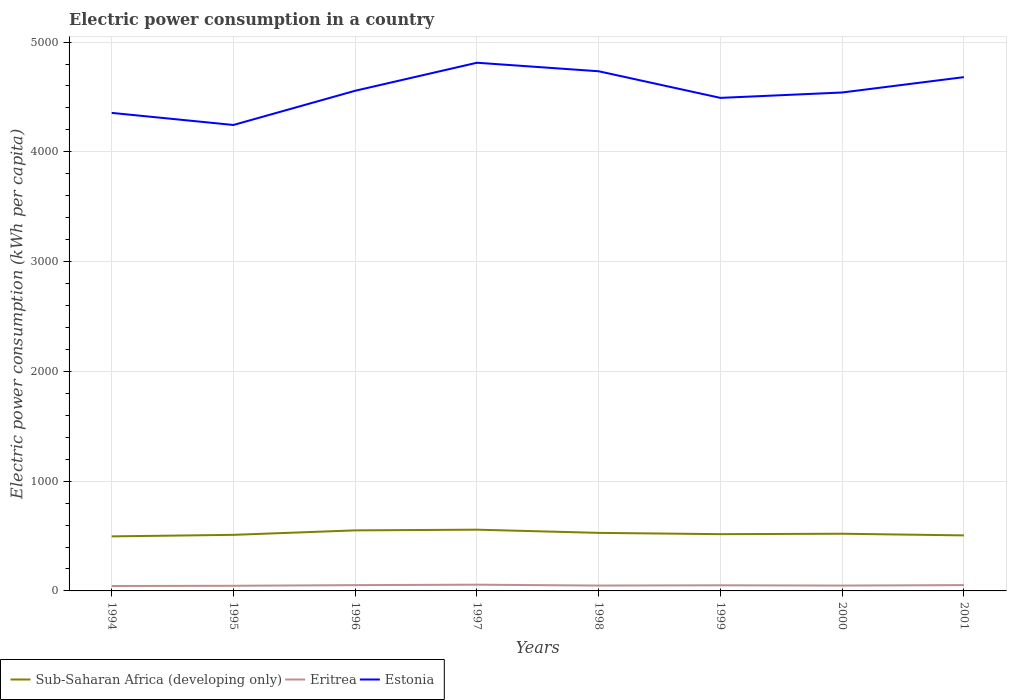How many different coloured lines are there?
Your answer should be compact. 3. Does the line corresponding to Eritrea intersect with the line corresponding to Sub-Saharan Africa (developing only)?
Offer a very short reply. No. Is the number of lines equal to the number of legend labels?
Offer a terse response. Yes. Across all years, what is the maximum electric power consumption in in Eritrea?
Keep it short and to the point. 44.79. In which year was the electric power consumption in in Sub-Saharan Africa (developing only) maximum?
Ensure brevity in your answer.  1994. What is the total electric power consumption in in Eritrea in the graph?
Provide a succinct answer. 3.66. What is the difference between the highest and the second highest electric power consumption in in Estonia?
Make the answer very short. 566.95. Is the electric power consumption in in Eritrea strictly greater than the electric power consumption in in Sub-Saharan Africa (developing only) over the years?
Ensure brevity in your answer.  Yes. Does the graph contain any zero values?
Provide a short and direct response. No. Does the graph contain grids?
Offer a terse response. Yes. How are the legend labels stacked?
Give a very brief answer. Horizontal. What is the title of the graph?
Offer a terse response. Electric power consumption in a country. Does "High income: nonOECD" appear as one of the legend labels in the graph?
Keep it short and to the point. No. What is the label or title of the X-axis?
Give a very brief answer. Years. What is the label or title of the Y-axis?
Your answer should be very brief. Electric power consumption (kWh per capita). What is the Electric power consumption (kWh per capita) in Sub-Saharan Africa (developing only) in 1994?
Your answer should be very brief. 496.9. What is the Electric power consumption (kWh per capita) in Eritrea in 1994?
Provide a short and direct response. 44.79. What is the Electric power consumption (kWh per capita) in Estonia in 1994?
Provide a short and direct response. 4354.83. What is the Electric power consumption (kWh per capita) in Sub-Saharan Africa (developing only) in 1995?
Your response must be concise. 510.9. What is the Electric power consumption (kWh per capita) of Eritrea in 1995?
Make the answer very short. 46.77. What is the Electric power consumption (kWh per capita) in Estonia in 1995?
Your answer should be very brief. 4244.64. What is the Electric power consumption (kWh per capita) of Sub-Saharan Africa (developing only) in 1996?
Make the answer very short. 551.54. What is the Electric power consumption (kWh per capita) of Eritrea in 1996?
Offer a very short reply. 52.77. What is the Electric power consumption (kWh per capita) in Estonia in 1996?
Ensure brevity in your answer.  4556.39. What is the Electric power consumption (kWh per capita) of Sub-Saharan Africa (developing only) in 1997?
Keep it short and to the point. 557.91. What is the Electric power consumption (kWh per capita) of Eritrea in 1997?
Provide a short and direct response. 56.74. What is the Electric power consumption (kWh per capita) of Estonia in 1997?
Offer a very short reply. 4811.6. What is the Electric power consumption (kWh per capita) in Sub-Saharan Africa (developing only) in 1998?
Your response must be concise. 528.77. What is the Electric power consumption (kWh per capita) in Eritrea in 1998?
Ensure brevity in your answer.  48.84. What is the Electric power consumption (kWh per capita) of Estonia in 1998?
Offer a very short reply. 4733.95. What is the Electric power consumption (kWh per capita) in Sub-Saharan Africa (developing only) in 1999?
Offer a terse response. 517.1. What is the Electric power consumption (kWh per capita) in Eritrea in 1999?
Give a very brief answer. 51.32. What is the Electric power consumption (kWh per capita) in Estonia in 1999?
Offer a very short reply. 4491.46. What is the Electric power consumption (kWh per capita) of Sub-Saharan Africa (developing only) in 2000?
Your response must be concise. 520.97. What is the Electric power consumption (kWh per capita) of Eritrea in 2000?
Your answer should be compact. 48.65. What is the Electric power consumption (kWh per capita) in Estonia in 2000?
Provide a succinct answer. 4540.49. What is the Electric power consumption (kWh per capita) in Sub-Saharan Africa (developing only) in 2001?
Make the answer very short. 505.86. What is the Electric power consumption (kWh per capita) in Eritrea in 2001?
Your answer should be compact. 53.08. What is the Electric power consumption (kWh per capita) in Estonia in 2001?
Ensure brevity in your answer.  4680.45. Across all years, what is the maximum Electric power consumption (kWh per capita) in Sub-Saharan Africa (developing only)?
Your answer should be very brief. 557.91. Across all years, what is the maximum Electric power consumption (kWh per capita) in Eritrea?
Give a very brief answer. 56.74. Across all years, what is the maximum Electric power consumption (kWh per capita) in Estonia?
Give a very brief answer. 4811.6. Across all years, what is the minimum Electric power consumption (kWh per capita) of Sub-Saharan Africa (developing only)?
Give a very brief answer. 496.9. Across all years, what is the minimum Electric power consumption (kWh per capita) of Eritrea?
Ensure brevity in your answer.  44.79. Across all years, what is the minimum Electric power consumption (kWh per capita) of Estonia?
Your response must be concise. 4244.64. What is the total Electric power consumption (kWh per capita) in Sub-Saharan Africa (developing only) in the graph?
Keep it short and to the point. 4189.94. What is the total Electric power consumption (kWh per capita) in Eritrea in the graph?
Make the answer very short. 402.97. What is the total Electric power consumption (kWh per capita) in Estonia in the graph?
Your response must be concise. 3.64e+04. What is the difference between the Electric power consumption (kWh per capita) of Sub-Saharan Africa (developing only) in 1994 and that in 1995?
Ensure brevity in your answer.  -14. What is the difference between the Electric power consumption (kWh per capita) in Eritrea in 1994 and that in 1995?
Your answer should be very brief. -1.98. What is the difference between the Electric power consumption (kWh per capita) of Estonia in 1994 and that in 1995?
Your response must be concise. 110.19. What is the difference between the Electric power consumption (kWh per capita) of Sub-Saharan Africa (developing only) in 1994 and that in 1996?
Provide a short and direct response. -54.65. What is the difference between the Electric power consumption (kWh per capita) of Eritrea in 1994 and that in 1996?
Your response must be concise. -7.98. What is the difference between the Electric power consumption (kWh per capita) in Estonia in 1994 and that in 1996?
Make the answer very short. -201.56. What is the difference between the Electric power consumption (kWh per capita) of Sub-Saharan Africa (developing only) in 1994 and that in 1997?
Provide a short and direct response. -61.02. What is the difference between the Electric power consumption (kWh per capita) of Eritrea in 1994 and that in 1997?
Make the answer very short. -11.95. What is the difference between the Electric power consumption (kWh per capita) in Estonia in 1994 and that in 1997?
Make the answer very short. -456.77. What is the difference between the Electric power consumption (kWh per capita) in Sub-Saharan Africa (developing only) in 1994 and that in 1998?
Your response must be concise. -31.87. What is the difference between the Electric power consumption (kWh per capita) of Eritrea in 1994 and that in 1998?
Provide a succinct answer. -4.05. What is the difference between the Electric power consumption (kWh per capita) of Estonia in 1994 and that in 1998?
Make the answer very short. -379.12. What is the difference between the Electric power consumption (kWh per capita) of Sub-Saharan Africa (developing only) in 1994 and that in 1999?
Make the answer very short. -20.2. What is the difference between the Electric power consumption (kWh per capita) in Eritrea in 1994 and that in 1999?
Give a very brief answer. -6.52. What is the difference between the Electric power consumption (kWh per capita) in Estonia in 1994 and that in 1999?
Offer a very short reply. -136.63. What is the difference between the Electric power consumption (kWh per capita) in Sub-Saharan Africa (developing only) in 1994 and that in 2000?
Provide a short and direct response. -24.07. What is the difference between the Electric power consumption (kWh per capita) in Eritrea in 1994 and that in 2000?
Offer a very short reply. -3.86. What is the difference between the Electric power consumption (kWh per capita) of Estonia in 1994 and that in 2000?
Offer a very short reply. -185.66. What is the difference between the Electric power consumption (kWh per capita) of Sub-Saharan Africa (developing only) in 1994 and that in 2001?
Your answer should be compact. -8.96. What is the difference between the Electric power consumption (kWh per capita) of Eritrea in 1994 and that in 2001?
Your answer should be very brief. -8.29. What is the difference between the Electric power consumption (kWh per capita) of Estonia in 1994 and that in 2001?
Your response must be concise. -325.62. What is the difference between the Electric power consumption (kWh per capita) in Sub-Saharan Africa (developing only) in 1995 and that in 1996?
Give a very brief answer. -40.64. What is the difference between the Electric power consumption (kWh per capita) in Eritrea in 1995 and that in 1996?
Ensure brevity in your answer.  -5.99. What is the difference between the Electric power consumption (kWh per capita) of Estonia in 1995 and that in 1996?
Make the answer very short. -311.75. What is the difference between the Electric power consumption (kWh per capita) of Sub-Saharan Africa (developing only) in 1995 and that in 1997?
Give a very brief answer. -47.01. What is the difference between the Electric power consumption (kWh per capita) of Eritrea in 1995 and that in 1997?
Your response must be concise. -9.96. What is the difference between the Electric power consumption (kWh per capita) of Estonia in 1995 and that in 1997?
Offer a very short reply. -566.95. What is the difference between the Electric power consumption (kWh per capita) in Sub-Saharan Africa (developing only) in 1995 and that in 1998?
Provide a succinct answer. -17.87. What is the difference between the Electric power consumption (kWh per capita) of Eritrea in 1995 and that in 1998?
Provide a succinct answer. -2.07. What is the difference between the Electric power consumption (kWh per capita) of Estonia in 1995 and that in 1998?
Provide a short and direct response. -489.31. What is the difference between the Electric power consumption (kWh per capita) of Sub-Saharan Africa (developing only) in 1995 and that in 1999?
Keep it short and to the point. -6.19. What is the difference between the Electric power consumption (kWh per capita) of Eritrea in 1995 and that in 1999?
Ensure brevity in your answer.  -4.54. What is the difference between the Electric power consumption (kWh per capita) in Estonia in 1995 and that in 1999?
Provide a short and direct response. -246.82. What is the difference between the Electric power consumption (kWh per capita) in Sub-Saharan Africa (developing only) in 1995 and that in 2000?
Keep it short and to the point. -10.07. What is the difference between the Electric power consumption (kWh per capita) of Eritrea in 1995 and that in 2000?
Keep it short and to the point. -1.88. What is the difference between the Electric power consumption (kWh per capita) in Estonia in 1995 and that in 2000?
Ensure brevity in your answer.  -295.85. What is the difference between the Electric power consumption (kWh per capita) in Sub-Saharan Africa (developing only) in 1995 and that in 2001?
Provide a succinct answer. 5.04. What is the difference between the Electric power consumption (kWh per capita) in Eritrea in 1995 and that in 2001?
Give a very brief answer. -6.3. What is the difference between the Electric power consumption (kWh per capita) in Estonia in 1995 and that in 2001?
Your answer should be compact. -435.8. What is the difference between the Electric power consumption (kWh per capita) of Sub-Saharan Africa (developing only) in 1996 and that in 1997?
Provide a short and direct response. -6.37. What is the difference between the Electric power consumption (kWh per capita) of Eritrea in 1996 and that in 1997?
Give a very brief answer. -3.97. What is the difference between the Electric power consumption (kWh per capita) of Estonia in 1996 and that in 1997?
Your response must be concise. -255.21. What is the difference between the Electric power consumption (kWh per capita) in Sub-Saharan Africa (developing only) in 1996 and that in 1998?
Provide a short and direct response. 22.77. What is the difference between the Electric power consumption (kWh per capita) of Eritrea in 1996 and that in 1998?
Ensure brevity in your answer.  3.93. What is the difference between the Electric power consumption (kWh per capita) in Estonia in 1996 and that in 1998?
Keep it short and to the point. -177.56. What is the difference between the Electric power consumption (kWh per capita) in Sub-Saharan Africa (developing only) in 1996 and that in 1999?
Ensure brevity in your answer.  34.45. What is the difference between the Electric power consumption (kWh per capita) of Eritrea in 1996 and that in 1999?
Keep it short and to the point. 1.45. What is the difference between the Electric power consumption (kWh per capita) of Estonia in 1996 and that in 1999?
Ensure brevity in your answer.  64.93. What is the difference between the Electric power consumption (kWh per capita) in Sub-Saharan Africa (developing only) in 1996 and that in 2000?
Offer a terse response. 30.57. What is the difference between the Electric power consumption (kWh per capita) in Eritrea in 1996 and that in 2000?
Your answer should be compact. 4.12. What is the difference between the Electric power consumption (kWh per capita) in Estonia in 1996 and that in 2000?
Give a very brief answer. 15.9. What is the difference between the Electric power consumption (kWh per capita) of Sub-Saharan Africa (developing only) in 1996 and that in 2001?
Offer a terse response. 45.69. What is the difference between the Electric power consumption (kWh per capita) of Eritrea in 1996 and that in 2001?
Provide a short and direct response. -0.31. What is the difference between the Electric power consumption (kWh per capita) in Estonia in 1996 and that in 2001?
Give a very brief answer. -124.06. What is the difference between the Electric power consumption (kWh per capita) in Sub-Saharan Africa (developing only) in 1997 and that in 1998?
Make the answer very short. 29.15. What is the difference between the Electric power consumption (kWh per capita) of Eritrea in 1997 and that in 1998?
Provide a succinct answer. 7.89. What is the difference between the Electric power consumption (kWh per capita) in Estonia in 1997 and that in 1998?
Offer a terse response. 77.64. What is the difference between the Electric power consumption (kWh per capita) in Sub-Saharan Africa (developing only) in 1997 and that in 1999?
Keep it short and to the point. 40.82. What is the difference between the Electric power consumption (kWh per capita) of Eritrea in 1997 and that in 1999?
Give a very brief answer. 5.42. What is the difference between the Electric power consumption (kWh per capita) in Estonia in 1997 and that in 1999?
Keep it short and to the point. 320.14. What is the difference between the Electric power consumption (kWh per capita) in Sub-Saharan Africa (developing only) in 1997 and that in 2000?
Keep it short and to the point. 36.94. What is the difference between the Electric power consumption (kWh per capita) of Eritrea in 1997 and that in 2000?
Ensure brevity in your answer.  8.08. What is the difference between the Electric power consumption (kWh per capita) of Estonia in 1997 and that in 2000?
Provide a short and direct response. 271.11. What is the difference between the Electric power consumption (kWh per capita) in Sub-Saharan Africa (developing only) in 1997 and that in 2001?
Make the answer very short. 52.06. What is the difference between the Electric power consumption (kWh per capita) of Eritrea in 1997 and that in 2001?
Offer a terse response. 3.66. What is the difference between the Electric power consumption (kWh per capita) of Estonia in 1997 and that in 2001?
Provide a succinct answer. 131.15. What is the difference between the Electric power consumption (kWh per capita) of Sub-Saharan Africa (developing only) in 1998 and that in 1999?
Your response must be concise. 11.67. What is the difference between the Electric power consumption (kWh per capita) in Eritrea in 1998 and that in 1999?
Provide a short and direct response. -2.47. What is the difference between the Electric power consumption (kWh per capita) in Estonia in 1998 and that in 1999?
Give a very brief answer. 242.49. What is the difference between the Electric power consumption (kWh per capita) in Sub-Saharan Africa (developing only) in 1998 and that in 2000?
Provide a succinct answer. 7.8. What is the difference between the Electric power consumption (kWh per capita) of Eritrea in 1998 and that in 2000?
Provide a succinct answer. 0.19. What is the difference between the Electric power consumption (kWh per capita) in Estonia in 1998 and that in 2000?
Give a very brief answer. 193.46. What is the difference between the Electric power consumption (kWh per capita) in Sub-Saharan Africa (developing only) in 1998 and that in 2001?
Give a very brief answer. 22.91. What is the difference between the Electric power consumption (kWh per capita) of Eritrea in 1998 and that in 2001?
Give a very brief answer. -4.23. What is the difference between the Electric power consumption (kWh per capita) in Estonia in 1998 and that in 2001?
Keep it short and to the point. 53.51. What is the difference between the Electric power consumption (kWh per capita) of Sub-Saharan Africa (developing only) in 1999 and that in 2000?
Give a very brief answer. -3.87. What is the difference between the Electric power consumption (kWh per capita) in Eritrea in 1999 and that in 2000?
Your answer should be compact. 2.66. What is the difference between the Electric power consumption (kWh per capita) in Estonia in 1999 and that in 2000?
Ensure brevity in your answer.  -49.03. What is the difference between the Electric power consumption (kWh per capita) in Sub-Saharan Africa (developing only) in 1999 and that in 2001?
Your answer should be very brief. 11.24. What is the difference between the Electric power consumption (kWh per capita) in Eritrea in 1999 and that in 2001?
Provide a short and direct response. -1.76. What is the difference between the Electric power consumption (kWh per capita) in Estonia in 1999 and that in 2001?
Your answer should be compact. -188.99. What is the difference between the Electric power consumption (kWh per capita) in Sub-Saharan Africa (developing only) in 2000 and that in 2001?
Offer a very short reply. 15.11. What is the difference between the Electric power consumption (kWh per capita) in Eritrea in 2000 and that in 2001?
Offer a terse response. -4.42. What is the difference between the Electric power consumption (kWh per capita) in Estonia in 2000 and that in 2001?
Give a very brief answer. -139.96. What is the difference between the Electric power consumption (kWh per capita) in Sub-Saharan Africa (developing only) in 1994 and the Electric power consumption (kWh per capita) in Eritrea in 1995?
Provide a succinct answer. 450.12. What is the difference between the Electric power consumption (kWh per capita) of Sub-Saharan Africa (developing only) in 1994 and the Electric power consumption (kWh per capita) of Estonia in 1995?
Keep it short and to the point. -3747.75. What is the difference between the Electric power consumption (kWh per capita) of Eritrea in 1994 and the Electric power consumption (kWh per capita) of Estonia in 1995?
Your answer should be compact. -4199.85. What is the difference between the Electric power consumption (kWh per capita) of Sub-Saharan Africa (developing only) in 1994 and the Electric power consumption (kWh per capita) of Eritrea in 1996?
Your answer should be compact. 444.13. What is the difference between the Electric power consumption (kWh per capita) in Sub-Saharan Africa (developing only) in 1994 and the Electric power consumption (kWh per capita) in Estonia in 1996?
Provide a short and direct response. -4059.49. What is the difference between the Electric power consumption (kWh per capita) of Eritrea in 1994 and the Electric power consumption (kWh per capita) of Estonia in 1996?
Your answer should be very brief. -4511.6. What is the difference between the Electric power consumption (kWh per capita) in Sub-Saharan Africa (developing only) in 1994 and the Electric power consumption (kWh per capita) in Eritrea in 1997?
Keep it short and to the point. 440.16. What is the difference between the Electric power consumption (kWh per capita) in Sub-Saharan Africa (developing only) in 1994 and the Electric power consumption (kWh per capita) in Estonia in 1997?
Offer a terse response. -4314.7. What is the difference between the Electric power consumption (kWh per capita) in Eritrea in 1994 and the Electric power consumption (kWh per capita) in Estonia in 1997?
Provide a short and direct response. -4766.81. What is the difference between the Electric power consumption (kWh per capita) of Sub-Saharan Africa (developing only) in 1994 and the Electric power consumption (kWh per capita) of Eritrea in 1998?
Provide a short and direct response. 448.05. What is the difference between the Electric power consumption (kWh per capita) of Sub-Saharan Africa (developing only) in 1994 and the Electric power consumption (kWh per capita) of Estonia in 1998?
Your answer should be very brief. -4237.06. What is the difference between the Electric power consumption (kWh per capita) of Eritrea in 1994 and the Electric power consumption (kWh per capita) of Estonia in 1998?
Keep it short and to the point. -4689.16. What is the difference between the Electric power consumption (kWh per capita) in Sub-Saharan Africa (developing only) in 1994 and the Electric power consumption (kWh per capita) in Eritrea in 1999?
Provide a short and direct response. 445.58. What is the difference between the Electric power consumption (kWh per capita) of Sub-Saharan Africa (developing only) in 1994 and the Electric power consumption (kWh per capita) of Estonia in 1999?
Give a very brief answer. -3994.56. What is the difference between the Electric power consumption (kWh per capita) of Eritrea in 1994 and the Electric power consumption (kWh per capita) of Estonia in 1999?
Offer a terse response. -4446.67. What is the difference between the Electric power consumption (kWh per capita) of Sub-Saharan Africa (developing only) in 1994 and the Electric power consumption (kWh per capita) of Eritrea in 2000?
Keep it short and to the point. 448.24. What is the difference between the Electric power consumption (kWh per capita) of Sub-Saharan Africa (developing only) in 1994 and the Electric power consumption (kWh per capita) of Estonia in 2000?
Ensure brevity in your answer.  -4043.6. What is the difference between the Electric power consumption (kWh per capita) of Eritrea in 1994 and the Electric power consumption (kWh per capita) of Estonia in 2000?
Make the answer very short. -4495.7. What is the difference between the Electric power consumption (kWh per capita) of Sub-Saharan Africa (developing only) in 1994 and the Electric power consumption (kWh per capita) of Eritrea in 2001?
Provide a short and direct response. 443.82. What is the difference between the Electric power consumption (kWh per capita) of Sub-Saharan Africa (developing only) in 1994 and the Electric power consumption (kWh per capita) of Estonia in 2001?
Offer a terse response. -4183.55. What is the difference between the Electric power consumption (kWh per capita) of Eritrea in 1994 and the Electric power consumption (kWh per capita) of Estonia in 2001?
Make the answer very short. -4635.66. What is the difference between the Electric power consumption (kWh per capita) in Sub-Saharan Africa (developing only) in 1995 and the Electric power consumption (kWh per capita) in Eritrea in 1996?
Offer a very short reply. 458.13. What is the difference between the Electric power consumption (kWh per capita) in Sub-Saharan Africa (developing only) in 1995 and the Electric power consumption (kWh per capita) in Estonia in 1996?
Offer a terse response. -4045.49. What is the difference between the Electric power consumption (kWh per capita) in Eritrea in 1995 and the Electric power consumption (kWh per capita) in Estonia in 1996?
Provide a succinct answer. -4509.62. What is the difference between the Electric power consumption (kWh per capita) of Sub-Saharan Africa (developing only) in 1995 and the Electric power consumption (kWh per capita) of Eritrea in 1997?
Give a very brief answer. 454.16. What is the difference between the Electric power consumption (kWh per capita) in Sub-Saharan Africa (developing only) in 1995 and the Electric power consumption (kWh per capita) in Estonia in 1997?
Offer a very short reply. -4300.7. What is the difference between the Electric power consumption (kWh per capita) in Eritrea in 1995 and the Electric power consumption (kWh per capita) in Estonia in 1997?
Give a very brief answer. -4764.82. What is the difference between the Electric power consumption (kWh per capita) in Sub-Saharan Africa (developing only) in 1995 and the Electric power consumption (kWh per capita) in Eritrea in 1998?
Your response must be concise. 462.06. What is the difference between the Electric power consumption (kWh per capita) of Sub-Saharan Africa (developing only) in 1995 and the Electric power consumption (kWh per capita) of Estonia in 1998?
Your response must be concise. -4223.05. What is the difference between the Electric power consumption (kWh per capita) of Eritrea in 1995 and the Electric power consumption (kWh per capita) of Estonia in 1998?
Offer a terse response. -4687.18. What is the difference between the Electric power consumption (kWh per capita) of Sub-Saharan Africa (developing only) in 1995 and the Electric power consumption (kWh per capita) of Eritrea in 1999?
Provide a short and direct response. 459.58. What is the difference between the Electric power consumption (kWh per capita) in Sub-Saharan Africa (developing only) in 1995 and the Electric power consumption (kWh per capita) in Estonia in 1999?
Keep it short and to the point. -3980.56. What is the difference between the Electric power consumption (kWh per capita) in Eritrea in 1995 and the Electric power consumption (kWh per capita) in Estonia in 1999?
Your answer should be compact. -4444.69. What is the difference between the Electric power consumption (kWh per capita) of Sub-Saharan Africa (developing only) in 1995 and the Electric power consumption (kWh per capita) of Eritrea in 2000?
Offer a terse response. 462.25. What is the difference between the Electric power consumption (kWh per capita) of Sub-Saharan Africa (developing only) in 1995 and the Electric power consumption (kWh per capita) of Estonia in 2000?
Keep it short and to the point. -4029.59. What is the difference between the Electric power consumption (kWh per capita) of Eritrea in 1995 and the Electric power consumption (kWh per capita) of Estonia in 2000?
Your answer should be compact. -4493.72. What is the difference between the Electric power consumption (kWh per capita) of Sub-Saharan Africa (developing only) in 1995 and the Electric power consumption (kWh per capita) of Eritrea in 2001?
Your answer should be compact. 457.82. What is the difference between the Electric power consumption (kWh per capita) in Sub-Saharan Africa (developing only) in 1995 and the Electric power consumption (kWh per capita) in Estonia in 2001?
Offer a terse response. -4169.55. What is the difference between the Electric power consumption (kWh per capita) in Eritrea in 1995 and the Electric power consumption (kWh per capita) in Estonia in 2001?
Give a very brief answer. -4633.67. What is the difference between the Electric power consumption (kWh per capita) of Sub-Saharan Africa (developing only) in 1996 and the Electric power consumption (kWh per capita) of Eritrea in 1997?
Offer a terse response. 494.8. What is the difference between the Electric power consumption (kWh per capita) in Sub-Saharan Africa (developing only) in 1996 and the Electric power consumption (kWh per capita) in Estonia in 1997?
Ensure brevity in your answer.  -4260.06. What is the difference between the Electric power consumption (kWh per capita) in Eritrea in 1996 and the Electric power consumption (kWh per capita) in Estonia in 1997?
Offer a very short reply. -4758.83. What is the difference between the Electric power consumption (kWh per capita) in Sub-Saharan Africa (developing only) in 1996 and the Electric power consumption (kWh per capita) in Eritrea in 1998?
Offer a terse response. 502.7. What is the difference between the Electric power consumption (kWh per capita) of Sub-Saharan Africa (developing only) in 1996 and the Electric power consumption (kWh per capita) of Estonia in 1998?
Keep it short and to the point. -4182.41. What is the difference between the Electric power consumption (kWh per capita) in Eritrea in 1996 and the Electric power consumption (kWh per capita) in Estonia in 1998?
Ensure brevity in your answer.  -4681.19. What is the difference between the Electric power consumption (kWh per capita) in Sub-Saharan Africa (developing only) in 1996 and the Electric power consumption (kWh per capita) in Eritrea in 1999?
Your answer should be compact. 500.22. What is the difference between the Electric power consumption (kWh per capita) of Sub-Saharan Africa (developing only) in 1996 and the Electric power consumption (kWh per capita) of Estonia in 1999?
Make the answer very short. -3939.92. What is the difference between the Electric power consumption (kWh per capita) of Eritrea in 1996 and the Electric power consumption (kWh per capita) of Estonia in 1999?
Provide a short and direct response. -4438.69. What is the difference between the Electric power consumption (kWh per capita) in Sub-Saharan Africa (developing only) in 1996 and the Electric power consumption (kWh per capita) in Eritrea in 2000?
Offer a very short reply. 502.89. What is the difference between the Electric power consumption (kWh per capita) of Sub-Saharan Africa (developing only) in 1996 and the Electric power consumption (kWh per capita) of Estonia in 2000?
Give a very brief answer. -3988.95. What is the difference between the Electric power consumption (kWh per capita) of Eritrea in 1996 and the Electric power consumption (kWh per capita) of Estonia in 2000?
Make the answer very short. -4487.72. What is the difference between the Electric power consumption (kWh per capita) of Sub-Saharan Africa (developing only) in 1996 and the Electric power consumption (kWh per capita) of Eritrea in 2001?
Keep it short and to the point. 498.46. What is the difference between the Electric power consumption (kWh per capita) of Sub-Saharan Africa (developing only) in 1996 and the Electric power consumption (kWh per capita) of Estonia in 2001?
Provide a short and direct response. -4128.91. What is the difference between the Electric power consumption (kWh per capita) of Eritrea in 1996 and the Electric power consumption (kWh per capita) of Estonia in 2001?
Your answer should be compact. -4627.68. What is the difference between the Electric power consumption (kWh per capita) of Sub-Saharan Africa (developing only) in 1997 and the Electric power consumption (kWh per capita) of Eritrea in 1998?
Ensure brevity in your answer.  509.07. What is the difference between the Electric power consumption (kWh per capita) of Sub-Saharan Africa (developing only) in 1997 and the Electric power consumption (kWh per capita) of Estonia in 1998?
Your answer should be compact. -4176.04. What is the difference between the Electric power consumption (kWh per capita) in Eritrea in 1997 and the Electric power consumption (kWh per capita) in Estonia in 1998?
Your answer should be compact. -4677.22. What is the difference between the Electric power consumption (kWh per capita) in Sub-Saharan Africa (developing only) in 1997 and the Electric power consumption (kWh per capita) in Eritrea in 1999?
Provide a succinct answer. 506.6. What is the difference between the Electric power consumption (kWh per capita) of Sub-Saharan Africa (developing only) in 1997 and the Electric power consumption (kWh per capita) of Estonia in 1999?
Your answer should be very brief. -3933.55. What is the difference between the Electric power consumption (kWh per capita) of Eritrea in 1997 and the Electric power consumption (kWh per capita) of Estonia in 1999?
Keep it short and to the point. -4434.72. What is the difference between the Electric power consumption (kWh per capita) in Sub-Saharan Africa (developing only) in 1997 and the Electric power consumption (kWh per capita) in Eritrea in 2000?
Provide a short and direct response. 509.26. What is the difference between the Electric power consumption (kWh per capita) of Sub-Saharan Africa (developing only) in 1997 and the Electric power consumption (kWh per capita) of Estonia in 2000?
Provide a short and direct response. -3982.58. What is the difference between the Electric power consumption (kWh per capita) of Eritrea in 1997 and the Electric power consumption (kWh per capita) of Estonia in 2000?
Your response must be concise. -4483.75. What is the difference between the Electric power consumption (kWh per capita) of Sub-Saharan Africa (developing only) in 1997 and the Electric power consumption (kWh per capita) of Eritrea in 2001?
Make the answer very short. 504.84. What is the difference between the Electric power consumption (kWh per capita) of Sub-Saharan Africa (developing only) in 1997 and the Electric power consumption (kWh per capita) of Estonia in 2001?
Your response must be concise. -4122.53. What is the difference between the Electric power consumption (kWh per capita) in Eritrea in 1997 and the Electric power consumption (kWh per capita) in Estonia in 2001?
Provide a succinct answer. -4623.71. What is the difference between the Electric power consumption (kWh per capita) of Sub-Saharan Africa (developing only) in 1998 and the Electric power consumption (kWh per capita) of Eritrea in 1999?
Keep it short and to the point. 477.45. What is the difference between the Electric power consumption (kWh per capita) of Sub-Saharan Africa (developing only) in 1998 and the Electric power consumption (kWh per capita) of Estonia in 1999?
Ensure brevity in your answer.  -3962.69. What is the difference between the Electric power consumption (kWh per capita) of Eritrea in 1998 and the Electric power consumption (kWh per capita) of Estonia in 1999?
Ensure brevity in your answer.  -4442.62. What is the difference between the Electric power consumption (kWh per capita) in Sub-Saharan Africa (developing only) in 1998 and the Electric power consumption (kWh per capita) in Eritrea in 2000?
Give a very brief answer. 480.11. What is the difference between the Electric power consumption (kWh per capita) in Sub-Saharan Africa (developing only) in 1998 and the Electric power consumption (kWh per capita) in Estonia in 2000?
Provide a succinct answer. -4011.72. What is the difference between the Electric power consumption (kWh per capita) in Eritrea in 1998 and the Electric power consumption (kWh per capita) in Estonia in 2000?
Give a very brief answer. -4491.65. What is the difference between the Electric power consumption (kWh per capita) of Sub-Saharan Africa (developing only) in 1998 and the Electric power consumption (kWh per capita) of Eritrea in 2001?
Your answer should be very brief. 475.69. What is the difference between the Electric power consumption (kWh per capita) in Sub-Saharan Africa (developing only) in 1998 and the Electric power consumption (kWh per capita) in Estonia in 2001?
Offer a terse response. -4151.68. What is the difference between the Electric power consumption (kWh per capita) in Eritrea in 1998 and the Electric power consumption (kWh per capita) in Estonia in 2001?
Your answer should be compact. -4631.6. What is the difference between the Electric power consumption (kWh per capita) in Sub-Saharan Africa (developing only) in 1999 and the Electric power consumption (kWh per capita) in Eritrea in 2000?
Provide a short and direct response. 468.44. What is the difference between the Electric power consumption (kWh per capita) of Sub-Saharan Africa (developing only) in 1999 and the Electric power consumption (kWh per capita) of Estonia in 2000?
Give a very brief answer. -4023.4. What is the difference between the Electric power consumption (kWh per capita) in Eritrea in 1999 and the Electric power consumption (kWh per capita) in Estonia in 2000?
Give a very brief answer. -4489.18. What is the difference between the Electric power consumption (kWh per capita) of Sub-Saharan Africa (developing only) in 1999 and the Electric power consumption (kWh per capita) of Eritrea in 2001?
Your answer should be compact. 464.02. What is the difference between the Electric power consumption (kWh per capita) of Sub-Saharan Africa (developing only) in 1999 and the Electric power consumption (kWh per capita) of Estonia in 2001?
Your answer should be very brief. -4163.35. What is the difference between the Electric power consumption (kWh per capita) in Eritrea in 1999 and the Electric power consumption (kWh per capita) in Estonia in 2001?
Your response must be concise. -4629.13. What is the difference between the Electric power consumption (kWh per capita) in Sub-Saharan Africa (developing only) in 2000 and the Electric power consumption (kWh per capita) in Eritrea in 2001?
Provide a short and direct response. 467.89. What is the difference between the Electric power consumption (kWh per capita) in Sub-Saharan Africa (developing only) in 2000 and the Electric power consumption (kWh per capita) in Estonia in 2001?
Provide a succinct answer. -4159.48. What is the difference between the Electric power consumption (kWh per capita) of Eritrea in 2000 and the Electric power consumption (kWh per capita) of Estonia in 2001?
Offer a terse response. -4631.79. What is the average Electric power consumption (kWh per capita) in Sub-Saharan Africa (developing only) per year?
Make the answer very short. 523.74. What is the average Electric power consumption (kWh per capita) in Eritrea per year?
Your answer should be compact. 50.37. What is the average Electric power consumption (kWh per capita) in Estonia per year?
Keep it short and to the point. 4551.73. In the year 1994, what is the difference between the Electric power consumption (kWh per capita) of Sub-Saharan Africa (developing only) and Electric power consumption (kWh per capita) of Eritrea?
Make the answer very short. 452.1. In the year 1994, what is the difference between the Electric power consumption (kWh per capita) in Sub-Saharan Africa (developing only) and Electric power consumption (kWh per capita) in Estonia?
Your response must be concise. -3857.93. In the year 1994, what is the difference between the Electric power consumption (kWh per capita) of Eritrea and Electric power consumption (kWh per capita) of Estonia?
Provide a short and direct response. -4310.04. In the year 1995, what is the difference between the Electric power consumption (kWh per capita) in Sub-Saharan Africa (developing only) and Electric power consumption (kWh per capita) in Eritrea?
Ensure brevity in your answer.  464.13. In the year 1995, what is the difference between the Electric power consumption (kWh per capita) in Sub-Saharan Africa (developing only) and Electric power consumption (kWh per capita) in Estonia?
Keep it short and to the point. -3733.74. In the year 1995, what is the difference between the Electric power consumption (kWh per capita) in Eritrea and Electric power consumption (kWh per capita) in Estonia?
Ensure brevity in your answer.  -4197.87. In the year 1996, what is the difference between the Electric power consumption (kWh per capita) in Sub-Saharan Africa (developing only) and Electric power consumption (kWh per capita) in Eritrea?
Offer a terse response. 498.77. In the year 1996, what is the difference between the Electric power consumption (kWh per capita) in Sub-Saharan Africa (developing only) and Electric power consumption (kWh per capita) in Estonia?
Provide a short and direct response. -4004.85. In the year 1996, what is the difference between the Electric power consumption (kWh per capita) in Eritrea and Electric power consumption (kWh per capita) in Estonia?
Your answer should be very brief. -4503.62. In the year 1997, what is the difference between the Electric power consumption (kWh per capita) in Sub-Saharan Africa (developing only) and Electric power consumption (kWh per capita) in Eritrea?
Provide a short and direct response. 501.18. In the year 1997, what is the difference between the Electric power consumption (kWh per capita) of Sub-Saharan Africa (developing only) and Electric power consumption (kWh per capita) of Estonia?
Ensure brevity in your answer.  -4253.68. In the year 1997, what is the difference between the Electric power consumption (kWh per capita) in Eritrea and Electric power consumption (kWh per capita) in Estonia?
Make the answer very short. -4754.86. In the year 1998, what is the difference between the Electric power consumption (kWh per capita) of Sub-Saharan Africa (developing only) and Electric power consumption (kWh per capita) of Eritrea?
Offer a terse response. 479.93. In the year 1998, what is the difference between the Electric power consumption (kWh per capita) of Sub-Saharan Africa (developing only) and Electric power consumption (kWh per capita) of Estonia?
Your response must be concise. -4205.19. In the year 1998, what is the difference between the Electric power consumption (kWh per capita) of Eritrea and Electric power consumption (kWh per capita) of Estonia?
Give a very brief answer. -4685.11. In the year 1999, what is the difference between the Electric power consumption (kWh per capita) of Sub-Saharan Africa (developing only) and Electric power consumption (kWh per capita) of Eritrea?
Provide a succinct answer. 465.78. In the year 1999, what is the difference between the Electric power consumption (kWh per capita) in Sub-Saharan Africa (developing only) and Electric power consumption (kWh per capita) in Estonia?
Your response must be concise. -3974.36. In the year 1999, what is the difference between the Electric power consumption (kWh per capita) of Eritrea and Electric power consumption (kWh per capita) of Estonia?
Your answer should be very brief. -4440.14. In the year 2000, what is the difference between the Electric power consumption (kWh per capita) of Sub-Saharan Africa (developing only) and Electric power consumption (kWh per capita) of Eritrea?
Offer a very short reply. 472.32. In the year 2000, what is the difference between the Electric power consumption (kWh per capita) in Sub-Saharan Africa (developing only) and Electric power consumption (kWh per capita) in Estonia?
Ensure brevity in your answer.  -4019.52. In the year 2000, what is the difference between the Electric power consumption (kWh per capita) in Eritrea and Electric power consumption (kWh per capita) in Estonia?
Ensure brevity in your answer.  -4491.84. In the year 2001, what is the difference between the Electric power consumption (kWh per capita) of Sub-Saharan Africa (developing only) and Electric power consumption (kWh per capita) of Eritrea?
Your answer should be very brief. 452.78. In the year 2001, what is the difference between the Electric power consumption (kWh per capita) of Sub-Saharan Africa (developing only) and Electric power consumption (kWh per capita) of Estonia?
Offer a very short reply. -4174.59. In the year 2001, what is the difference between the Electric power consumption (kWh per capita) in Eritrea and Electric power consumption (kWh per capita) in Estonia?
Make the answer very short. -4627.37. What is the ratio of the Electric power consumption (kWh per capita) in Sub-Saharan Africa (developing only) in 1994 to that in 1995?
Keep it short and to the point. 0.97. What is the ratio of the Electric power consumption (kWh per capita) in Eritrea in 1994 to that in 1995?
Give a very brief answer. 0.96. What is the ratio of the Electric power consumption (kWh per capita) in Estonia in 1994 to that in 1995?
Your answer should be very brief. 1.03. What is the ratio of the Electric power consumption (kWh per capita) of Sub-Saharan Africa (developing only) in 1994 to that in 1996?
Provide a short and direct response. 0.9. What is the ratio of the Electric power consumption (kWh per capita) in Eritrea in 1994 to that in 1996?
Your response must be concise. 0.85. What is the ratio of the Electric power consumption (kWh per capita) of Estonia in 1994 to that in 1996?
Make the answer very short. 0.96. What is the ratio of the Electric power consumption (kWh per capita) in Sub-Saharan Africa (developing only) in 1994 to that in 1997?
Give a very brief answer. 0.89. What is the ratio of the Electric power consumption (kWh per capita) in Eritrea in 1994 to that in 1997?
Provide a short and direct response. 0.79. What is the ratio of the Electric power consumption (kWh per capita) in Estonia in 1994 to that in 1997?
Give a very brief answer. 0.91. What is the ratio of the Electric power consumption (kWh per capita) in Sub-Saharan Africa (developing only) in 1994 to that in 1998?
Ensure brevity in your answer.  0.94. What is the ratio of the Electric power consumption (kWh per capita) of Eritrea in 1994 to that in 1998?
Ensure brevity in your answer.  0.92. What is the ratio of the Electric power consumption (kWh per capita) of Estonia in 1994 to that in 1998?
Keep it short and to the point. 0.92. What is the ratio of the Electric power consumption (kWh per capita) in Sub-Saharan Africa (developing only) in 1994 to that in 1999?
Your answer should be very brief. 0.96. What is the ratio of the Electric power consumption (kWh per capita) of Eritrea in 1994 to that in 1999?
Your answer should be compact. 0.87. What is the ratio of the Electric power consumption (kWh per capita) of Estonia in 1994 to that in 1999?
Give a very brief answer. 0.97. What is the ratio of the Electric power consumption (kWh per capita) in Sub-Saharan Africa (developing only) in 1994 to that in 2000?
Make the answer very short. 0.95. What is the ratio of the Electric power consumption (kWh per capita) of Eritrea in 1994 to that in 2000?
Provide a succinct answer. 0.92. What is the ratio of the Electric power consumption (kWh per capita) in Estonia in 1994 to that in 2000?
Your answer should be compact. 0.96. What is the ratio of the Electric power consumption (kWh per capita) in Sub-Saharan Africa (developing only) in 1994 to that in 2001?
Give a very brief answer. 0.98. What is the ratio of the Electric power consumption (kWh per capita) in Eritrea in 1994 to that in 2001?
Provide a succinct answer. 0.84. What is the ratio of the Electric power consumption (kWh per capita) of Estonia in 1994 to that in 2001?
Your answer should be very brief. 0.93. What is the ratio of the Electric power consumption (kWh per capita) in Sub-Saharan Africa (developing only) in 1995 to that in 1996?
Provide a short and direct response. 0.93. What is the ratio of the Electric power consumption (kWh per capita) of Eritrea in 1995 to that in 1996?
Your answer should be very brief. 0.89. What is the ratio of the Electric power consumption (kWh per capita) of Estonia in 1995 to that in 1996?
Provide a short and direct response. 0.93. What is the ratio of the Electric power consumption (kWh per capita) in Sub-Saharan Africa (developing only) in 1995 to that in 1997?
Make the answer very short. 0.92. What is the ratio of the Electric power consumption (kWh per capita) of Eritrea in 1995 to that in 1997?
Provide a succinct answer. 0.82. What is the ratio of the Electric power consumption (kWh per capita) in Estonia in 1995 to that in 1997?
Your response must be concise. 0.88. What is the ratio of the Electric power consumption (kWh per capita) of Sub-Saharan Africa (developing only) in 1995 to that in 1998?
Provide a succinct answer. 0.97. What is the ratio of the Electric power consumption (kWh per capita) in Eritrea in 1995 to that in 1998?
Make the answer very short. 0.96. What is the ratio of the Electric power consumption (kWh per capita) of Estonia in 1995 to that in 1998?
Provide a short and direct response. 0.9. What is the ratio of the Electric power consumption (kWh per capita) in Sub-Saharan Africa (developing only) in 1995 to that in 1999?
Make the answer very short. 0.99. What is the ratio of the Electric power consumption (kWh per capita) in Eritrea in 1995 to that in 1999?
Provide a succinct answer. 0.91. What is the ratio of the Electric power consumption (kWh per capita) in Estonia in 1995 to that in 1999?
Your response must be concise. 0.94. What is the ratio of the Electric power consumption (kWh per capita) of Sub-Saharan Africa (developing only) in 1995 to that in 2000?
Your response must be concise. 0.98. What is the ratio of the Electric power consumption (kWh per capita) in Eritrea in 1995 to that in 2000?
Offer a very short reply. 0.96. What is the ratio of the Electric power consumption (kWh per capita) of Estonia in 1995 to that in 2000?
Your answer should be very brief. 0.93. What is the ratio of the Electric power consumption (kWh per capita) in Eritrea in 1995 to that in 2001?
Give a very brief answer. 0.88. What is the ratio of the Electric power consumption (kWh per capita) of Estonia in 1995 to that in 2001?
Your answer should be compact. 0.91. What is the ratio of the Electric power consumption (kWh per capita) in Sub-Saharan Africa (developing only) in 1996 to that in 1997?
Offer a terse response. 0.99. What is the ratio of the Electric power consumption (kWh per capita) of Eritrea in 1996 to that in 1997?
Your response must be concise. 0.93. What is the ratio of the Electric power consumption (kWh per capita) of Estonia in 1996 to that in 1997?
Keep it short and to the point. 0.95. What is the ratio of the Electric power consumption (kWh per capita) in Sub-Saharan Africa (developing only) in 1996 to that in 1998?
Offer a very short reply. 1.04. What is the ratio of the Electric power consumption (kWh per capita) of Eritrea in 1996 to that in 1998?
Your response must be concise. 1.08. What is the ratio of the Electric power consumption (kWh per capita) in Estonia in 1996 to that in 1998?
Your answer should be compact. 0.96. What is the ratio of the Electric power consumption (kWh per capita) of Sub-Saharan Africa (developing only) in 1996 to that in 1999?
Your response must be concise. 1.07. What is the ratio of the Electric power consumption (kWh per capita) in Eritrea in 1996 to that in 1999?
Your answer should be very brief. 1.03. What is the ratio of the Electric power consumption (kWh per capita) in Estonia in 1996 to that in 1999?
Your answer should be very brief. 1.01. What is the ratio of the Electric power consumption (kWh per capita) of Sub-Saharan Africa (developing only) in 1996 to that in 2000?
Provide a short and direct response. 1.06. What is the ratio of the Electric power consumption (kWh per capita) of Eritrea in 1996 to that in 2000?
Offer a very short reply. 1.08. What is the ratio of the Electric power consumption (kWh per capita) in Estonia in 1996 to that in 2000?
Offer a very short reply. 1. What is the ratio of the Electric power consumption (kWh per capita) in Sub-Saharan Africa (developing only) in 1996 to that in 2001?
Offer a terse response. 1.09. What is the ratio of the Electric power consumption (kWh per capita) in Estonia in 1996 to that in 2001?
Keep it short and to the point. 0.97. What is the ratio of the Electric power consumption (kWh per capita) of Sub-Saharan Africa (developing only) in 1997 to that in 1998?
Offer a very short reply. 1.06. What is the ratio of the Electric power consumption (kWh per capita) of Eritrea in 1997 to that in 1998?
Offer a terse response. 1.16. What is the ratio of the Electric power consumption (kWh per capita) of Estonia in 1997 to that in 1998?
Your answer should be compact. 1.02. What is the ratio of the Electric power consumption (kWh per capita) in Sub-Saharan Africa (developing only) in 1997 to that in 1999?
Offer a terse response. 1.08. What is the ratio of the Electric power consumption (kWh per capita) of Eritrea in 1997 to that in 1999?
Your answer should be very brief. 1.11. What is the ratio of the Electric power consumption (kWh per capita) of Estonia in 1997 to that in 1999?
Your answer should be very brief. 1.07. What is the ratio of the Electric power consumption (kWh per capita) of Sub-Saharan Africa (developing only) in 1997 to that in 2000?
Your answer should be compact. 1.07. What is the ratio of the Electric power consumption (kWh per capita) in Eritrea in 1997 to that in 2000?
Provide a succinct answer. 1.17. What is the ratio of the Electric power consumption (kWh per capita) in Estonia in 1997 to that in 2000?
Provide a succinct answer. 1.06. What is the ratio of the Electric power consumption (kWh per capita) in Sub-Saharan Africa (developing only) in 1997 to that in 2001?
Your answer should be very brief. 1.1. What is the ratio of the Electric power consumption (kWh per capita) of Eritrea in 1997 to that in 2001?
Keep it short and to the point. 1.07. What is the ratio of the Electric power consumption (kWh per capita) in Estonia in 1997 to that in 2001?
Ensure brevity in your answer.  1.03. What is the ratio of the Electric power consumption (kWh per capita) in Sub-Saharan Africa (developing only) in 1998 to that in 1999?
Offer a very short reply. 1.02. What is the ratio of the Electric power consumption (kWh per capita) of Eritrea in 1998 to that in 1999?
Keep it short and to the point. 0.95. What is the ratio of the Electric power consumption (kWh per capita) of Estonia in 1998 to that in 1999?
Your response must be concise. 1.05. What is the ratio of the Electric power consumption (kWh per capita) of Sub-Saharan Africa (developing only) in 1998 to that in 2000?
Offer a terse response. 1.01. What is the ratio of the Electric power consumption (kWh per capita) in Estonia in 1998 to that in 2000?
Ensure brevity in your answer.  1.04. What is the ratio of the Electric power consumption (kWh per capita) of Sub-Saharan Africa (developing only) in 1998 to that in 2001?
Ensure brevity in your answer.  1.05. What is the ratio of the Electric power consumption (kWh per capita) of Eritrea in 1998 to that in 2001?
Keep it short and to the point. 0.92. What is the ratio of the Electric power consumption (kWh per capita) in Estonia in 1998 to that in 2001?
Ensure brevity in your answer.  1.01. What is the ratio of the Electric power consumption (kWh per capita) in Eritrea in 1999 to that in 2000?
Keep it short and to the point. 1.05. What is the ratio of the Electric power consumption (kWh per capita) in Estonia in 1999 to that in 2000?
Give a very brief answer. 0.99. What is the ratio of the Electric power consumption (kWh per capita) in Sub-Saharan Africa (developing only) in 1999 to that in 2001?
Ensure brevity in your answer.  1.02. What is the ratio of the Electric power consumption (kWh per capita) in Eritrea in 1999 to that in 2001?
Your response must be concise. 0.97. What is the ratio of the Electric power consumption (kWh per capita) in Estonia in 1999 to that in 2001?
Provide a succinct answer. 0.96. What is the ratio of the Electric power consumption (kWh per capita) in Sub-Saharan Africa (developing only) in 2000 to that in 2001?
Keep it short and to the point. 1.03. What is the ratio of the Electric power consumption (kWh per capita) in Estonia in 2000 to that in 2001?
Your answer should be very brief. 0.97. What is the difference between the highest and the second highest Electric power consumption (kWh per capita) of Sub-Saharan Africa (developing only)?
Keep it short and to the point. 6.37. What is the difference between the highest and the second highest Electric power consumption (kWh per capita) of Eritrea?
Provide a succinct answer. 3.66. What is the difference between the highest and the second highest Electric power consumption (kWh per capita) of Estonia?
Keep it short and to the point. 77.64. What is the difference between the highest and the lowest Electric power consumption (kWh per capita) of Sub-Saharan Africa (developing only)?
Offer a very short reply. 61.02. What is the difference between the highest and the lowest Electric power consumption (kWh per capita) in Eritrea?
Offer a very short reply. 11.95. What is the difference between the highest and the lowest Electric power consumption (kWh per capita) in Estonia?
Provide a short and direct response. 566.95. 